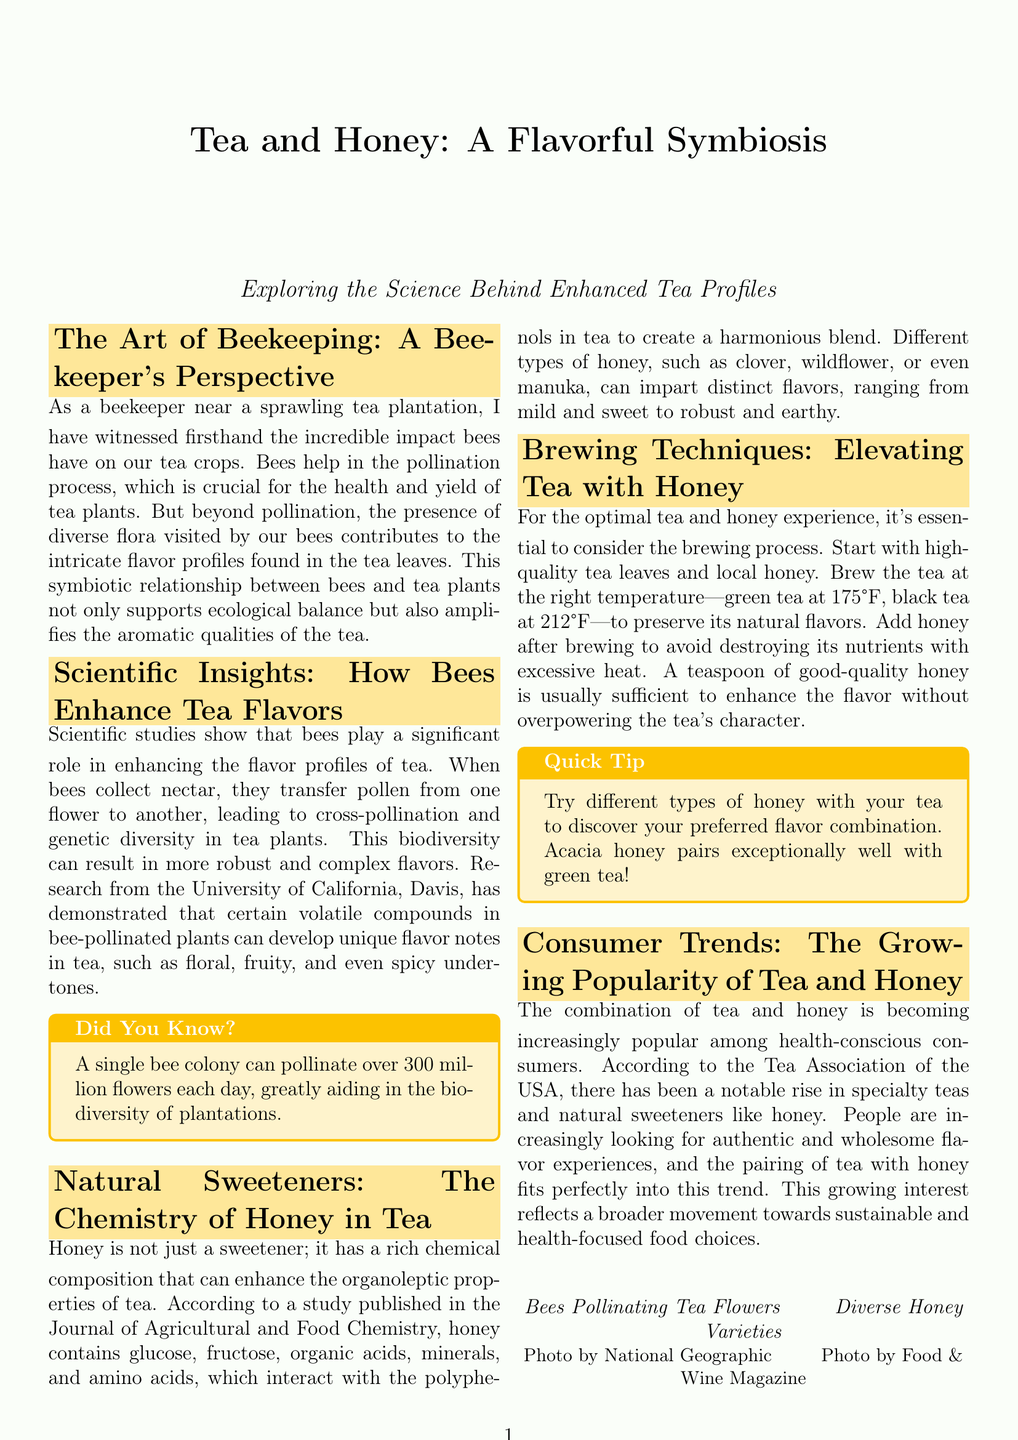What is the title of the document? The title is displayed prominently at the beginning of the document, which highlights the main topic.
Answer: Tea and Honey: A Flavorful Symbiosis Who published the study mentioned in the document about honey's chemical composition? The study cited in the document is published in a specific scientific journal related to food chemistry.
Answer: Journal of Agricultural and Food Chemistry What temperature is recommended for brewing green tea? The document specifies the ideal temperature for brewing different types of tea including green tea.
Answer: 175°F What type of honey pairs exceptionally well with green tea? The document provides a specific recommendation regarding honey types to enhance tea flavors.
Answer: Acacia honey How many flowers can a single bee colony pollinate each day? The document includes a fact about the pollination capacity of bee colonies for biodiversity.
Answer: 300 million flowers What is one key benefit of the symbiotic relationship between bees and tea plants? The relationship is described in terms of its impact on tea crop yield and flavor, providing an essential insight.
Answer: Enhances flavor profiles Which organization reported the rise in specialty teas and natural sweeteners? The source of the information regarding consumer trends is mentioned in relation to tea and natural sweeteners.
Answer: Tea Association of the USA What does honey contain that interacts with tea polyphenols? The document details the components of honey that contribute to its flavor-enhancing properties.
Answer: Glucose, fructose, organic acids, minerals, and amino acids 